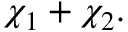<formula> <loc_0><loc_0><loc_500><loc_500>\chi _ { 1 } + \chi _ { 2 } .</formula> 